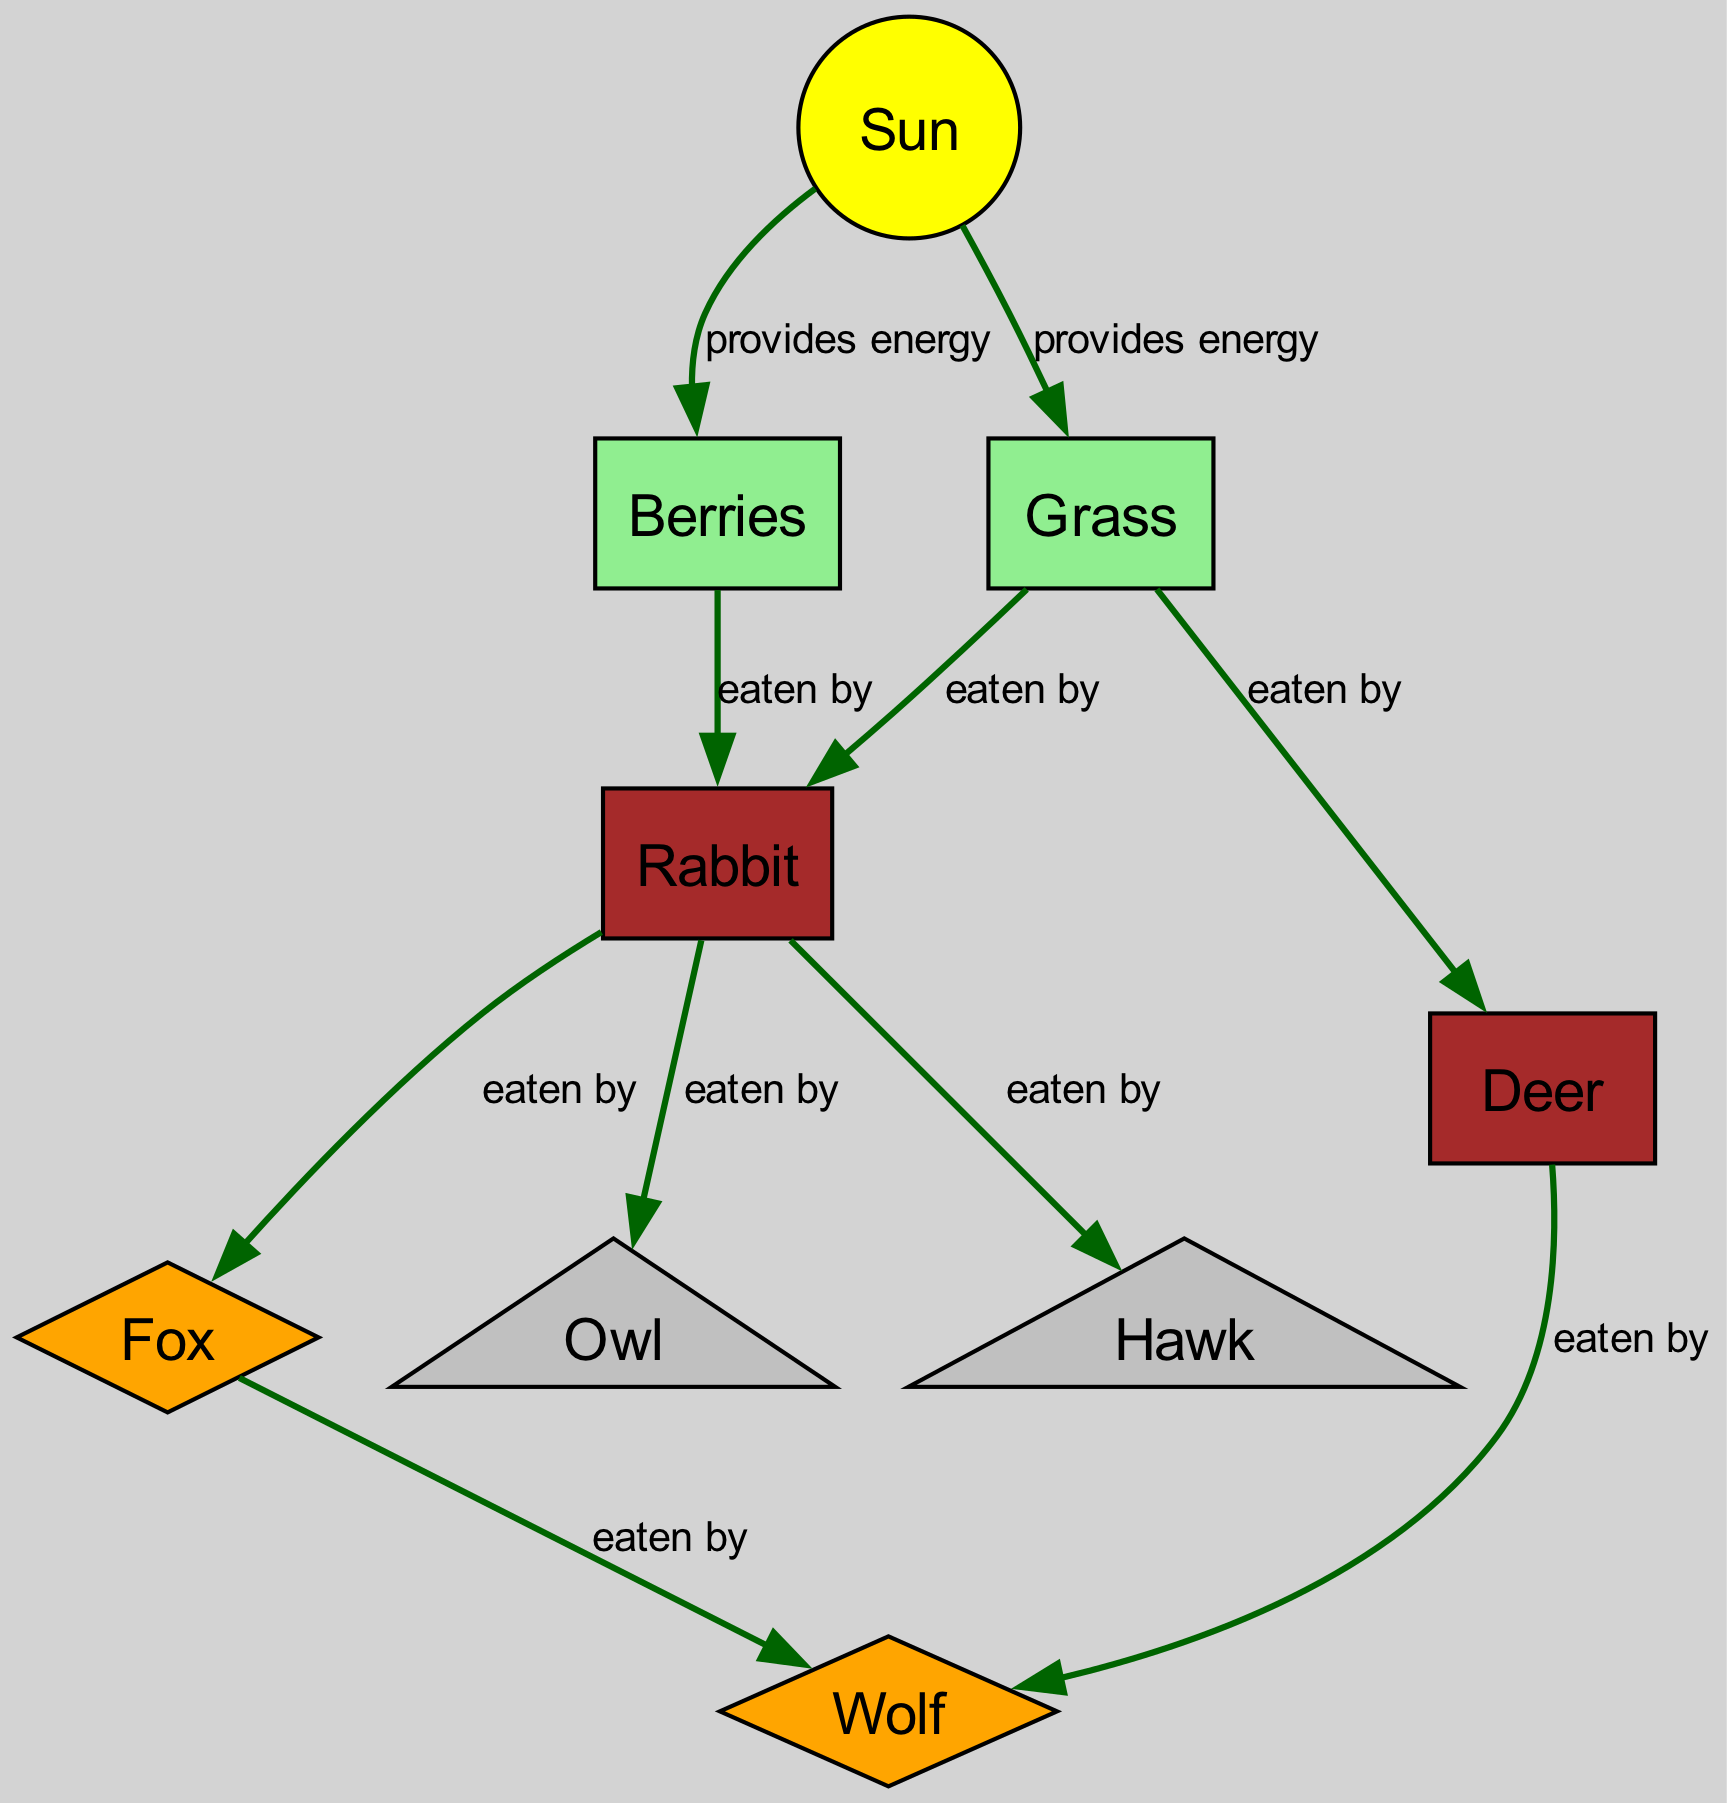What is the total number of nodes in the diagram? Counting the nodes listed in the data, there are 9 unique entities including the Sun, grass, berries, rabbit, deer, fox, wolf, owl, and hawk
Answer: 9 Which animal is eaten by the hawk? The data states that the rabbit is the only specified prey for the hawk
Answer: rabbit What provides energy to the grass? The diagram indicates that the Sun is the source of energy for the grass
Answer: Sun How many animals eat the rabbit? Based on the edges, the rabbit is eaten by the fox, owl, and hawk, totaling three predators
Answer: 3 What type of animal is the wolf? The diagram classifies the wolf as a carnivore predator, shown by its shape (diamond) and its position in the chain
Answer: predator Which two plants provide energy to the rabbit? The data shows that both grass and berries are sources of energy that are consumed by the rabbit
Answer: grass, berries What is the relationship between the deer and the wolf? According to the diagram, the deer is eaten by the wolf, indicating a predator-prey relationship
Answer: eaten by How many edges are there in total? By counting the connections (edges) between nodes in the provided data, there are 10 distinct relationships forming the food chain
Answer: 10 Which animal eats the deer? The data specifies that the wolf is the only predator listed as eating the deer
Answer: wolf 